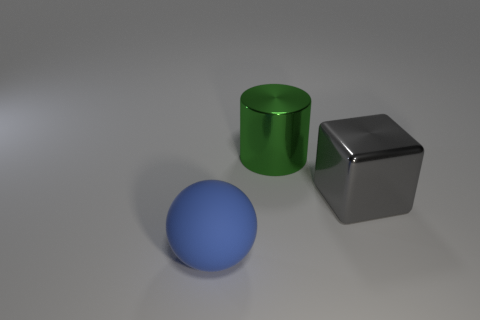What is the color of the shiny cube that is the same size as the blue matte sphere?
Give a very brief answer. Gray. What is the material of the large cube?
Keep it short and to the point. Metal. How many big green shiny balls are there?
Offer a terse response. 0. How many other things are there of the same size as the gray cube?
Provide a succinct answer. 2. There is a object that is on the left side of the big green object; what is its color?
Keep it short and to the point. Blue. Is the material of the big thing right of the big green cylinder the same as the green cylinder?
Keep it short and to the point. Yes. What number of large objects are both to the left of the large metal cylinder and right of the big matte thing?
Your answer should be very brief. 0. What is the color of the big shiny block that is in front of the thing that is behind the metallic block in front of the cylinder?
Give a very brief answer. Gray. How many other things are the same shape as the green metal object?
Provide a short and direct response. 0. Are there any cylinders that are behind the metal thing that is in front of the large cylinder?
Your answer should be compact. Yes. 